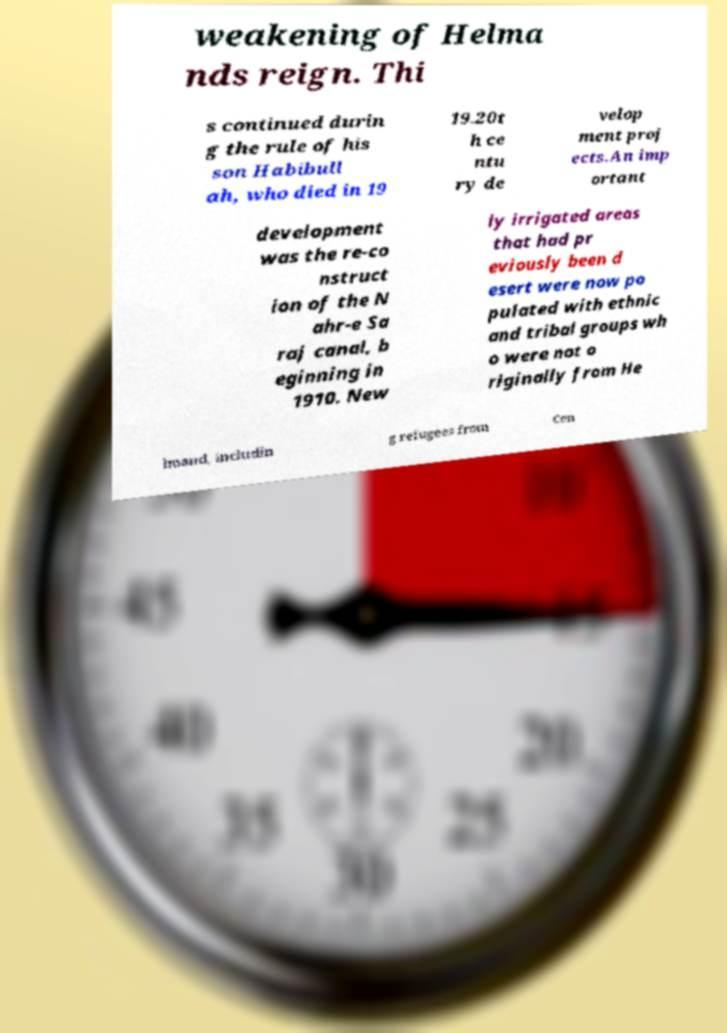Can you read and provide the text displayed in the image?This photo seems to have some interesting text. Can you extract and type it out for me? weakening of Helma nds reign. Thi s continued durin g the rule of his son Habibull ah, who died in 19 19.20t h ce ntu ry de velop ment proj ects.An imp ortant development was the re-co nstruct ion of the N ahr-e Sa raj canal, b eginning in 1910. New ly irrigated areas that had pr eviously been d esert were now po pulated with ethnic and tribal groups wh o were not o riginally from He lmand, includin g refugees from Cen 